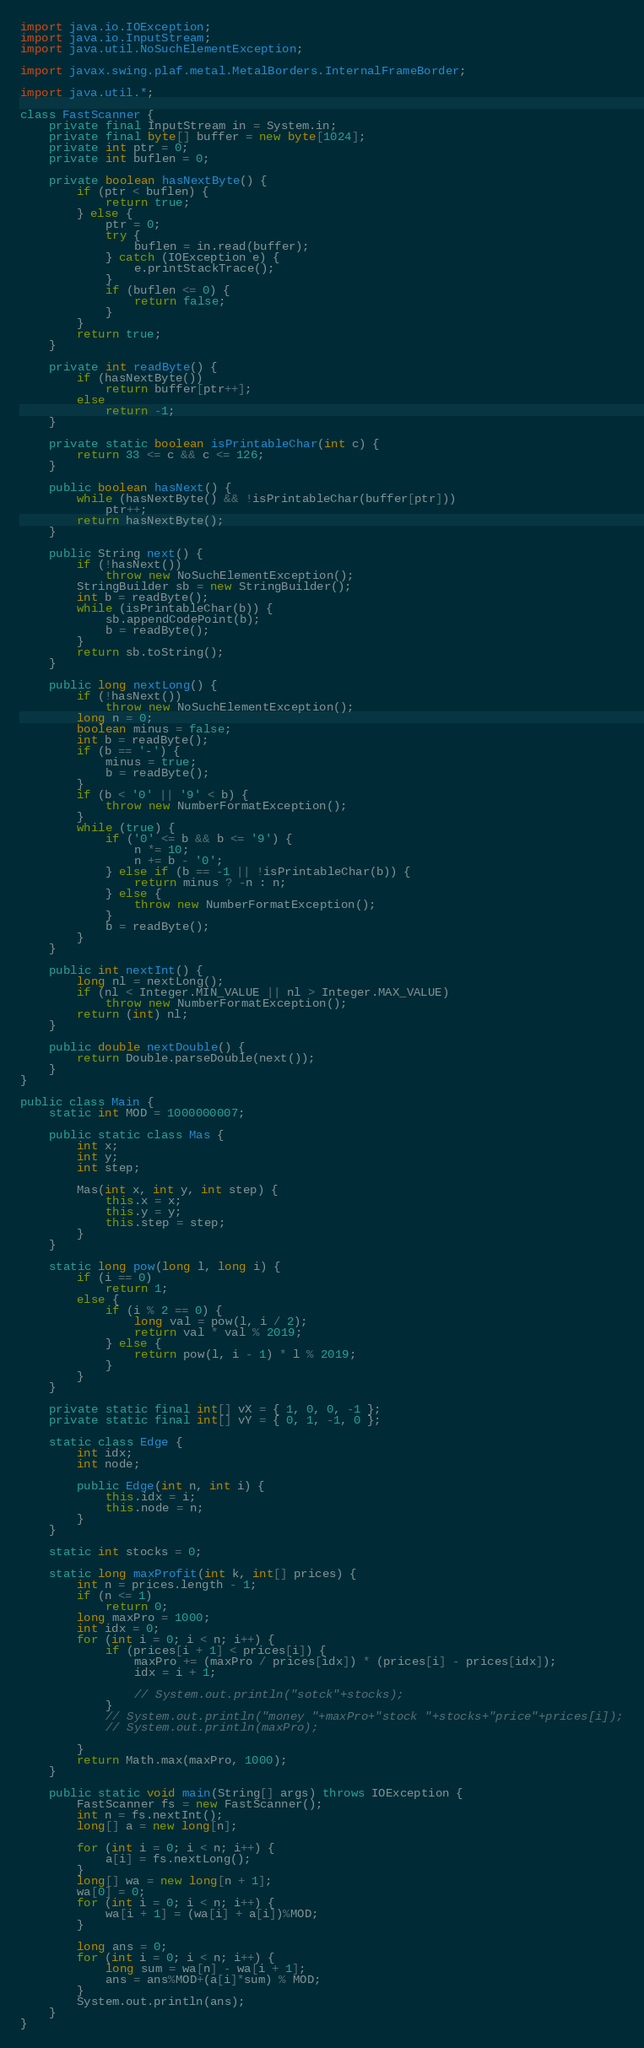Convert code to text. <code><loc_0><loc_0><loc_500><loc_500><_Java_>import java.io.IOException;
import java.io.InputStream;
import java.util.NoSuchElementException;

import javax.swing.plaf.metal.MetalBorders.InternalFrameBorder;

import java.util.*;

class FastScanner {
    private final InputStream in = System.in;
    private final byte[] buffer = new byte[1024];
    private int ptr = 0;
    private int buflen = 0;

    private boolean hasNextByte() {
        if (ptr < buflen) {
            return true;
        } else {
            ptr = 0;
            try {
                buflen = in.read(buffer);
            } catch (IOException e) {
                e.printStackTrace();
            }
            if (buflen <= 0) {
                return false;
            }
        }
        return true;
    }

    private int readByte() {
        if (hasNextByte())
            return buffer[ptr++];
        else
            return -1;
    }

    private static boolean isPrintableChar(int c) {
        return 33 <= c && c <= 126;
    }

    public boolean hasNext() {
        while (hasNextByte() && !isPrintableChar(buffer[ptr]))
            ptr++;
        return hasNextByte();
    }

    public String next() {
        if (!hasNext())
            throw new NoSuchElementException();
        StringBuilder sb = new StringBuilder();
        int b = readByte();
        while (isPrintableChar(b)) {
            sb.appendCodePoint(b);
            b = readByte();
        }
        return sb.toString();
    }

    public long nextLong() {
        if (!hasNext())
            throw new NoSuchElementException();
        long n = 0;
        boolean minus = false;
        int b = readByte();
        if (b == '-') {
            minus = true;
            b = readByte();
        }
        if (b < '0' || '9' < b) {
            throw new NumberFormatException();
        }
        while (true) {
            if ('0' <= b && b <= '9') {
                n *= 10;
                n += b - '0';
            } else if (b == -1 || !isPrintableChar(b)) {
                return minus ? -n : n;
            } else {
                throw new NumberFormatException();
            }
            b = readByte();
        }
    }

    public int nextInt() {
        long nl = nextLong();
        if (nl < Integer.MIN_VALUE || nl > Integer.MAX_VALUE)
            throw new NumberFormatException();
        return (int) nl;
    }

    public double nextDouble() {
        return Double.parseDouble(next());
    }
}

public class Main {
    static int MOD = 1000000007;

    public static class Mas {
        int x;
        int y;
        int step;

        Mas(int x, int y, int step) {
            this.x = x;
            this.y = y;
            this.step = step;
        }
    }

    static long pow(long l, long i) {
        if (i == 0)
            return 1;
        else {
            if (i % 2 == 0) {
                long val = pow(l, i / 2);
                return val * val % 2019;
            } else {
                return pow(l, i - 1) * l % 2019;
            }
        }
    }

    private static final int[] vX = { 1, 0, 0, -1 };
    private static final int[] vY = { 0, 1, -1, 0 };

    static class Edge {
        int idx;
        int node;

        public Edge(int n, int i) {
            this.idx = i;
            this.node = n;
        }
    }

    static int stocks = 0;

    static long maxProfit(int k, int[] prices) {
        int n = prices.length - 1;
        if (n <= 1)
            return 0;
        long maxPro = 1000;
        int idx = 0;
        for (int i = 0; i < n; i++) {
            if (prices[i + 1] < prices[i]) {
                maxPro += (maxPro / prices[idx]) * (prices[i] - prices[idx]);
                idx = i + 1;

                // System.out.println("sotck"+stocks);
            }
            // System.out.println("money "+maxPro+"stock "+stocks+"price"+prices[i]);
            // System.out.println(maxPro);

        }
        return Math.max(maxPro, 1000);
    }

    public static void main(String[] args) throws IOException {
        FastScanner fs = new FastScanner();
        int n = fs.nextInt();
        long[] a = new long[n];

        for (int i = 0; i < n; i++) {
            a[i] = fs.nextLong();
        }
        long[] wa = new long[n + 1];
        wa[0] = 0;
        for (int i = 0; i < n; i++) {
            wa[i + 1] = (wa[i] + a[i])%MOD;
        }

        long ans = 0;
        for (int i = 0; i < n; i++) {
            long sum = wa[n] - wa[i + 1];
            ans = ans%MOD+(a[i]*sum) % MOD;
        }
        System.out.println(ans);
    }
}
</code> 